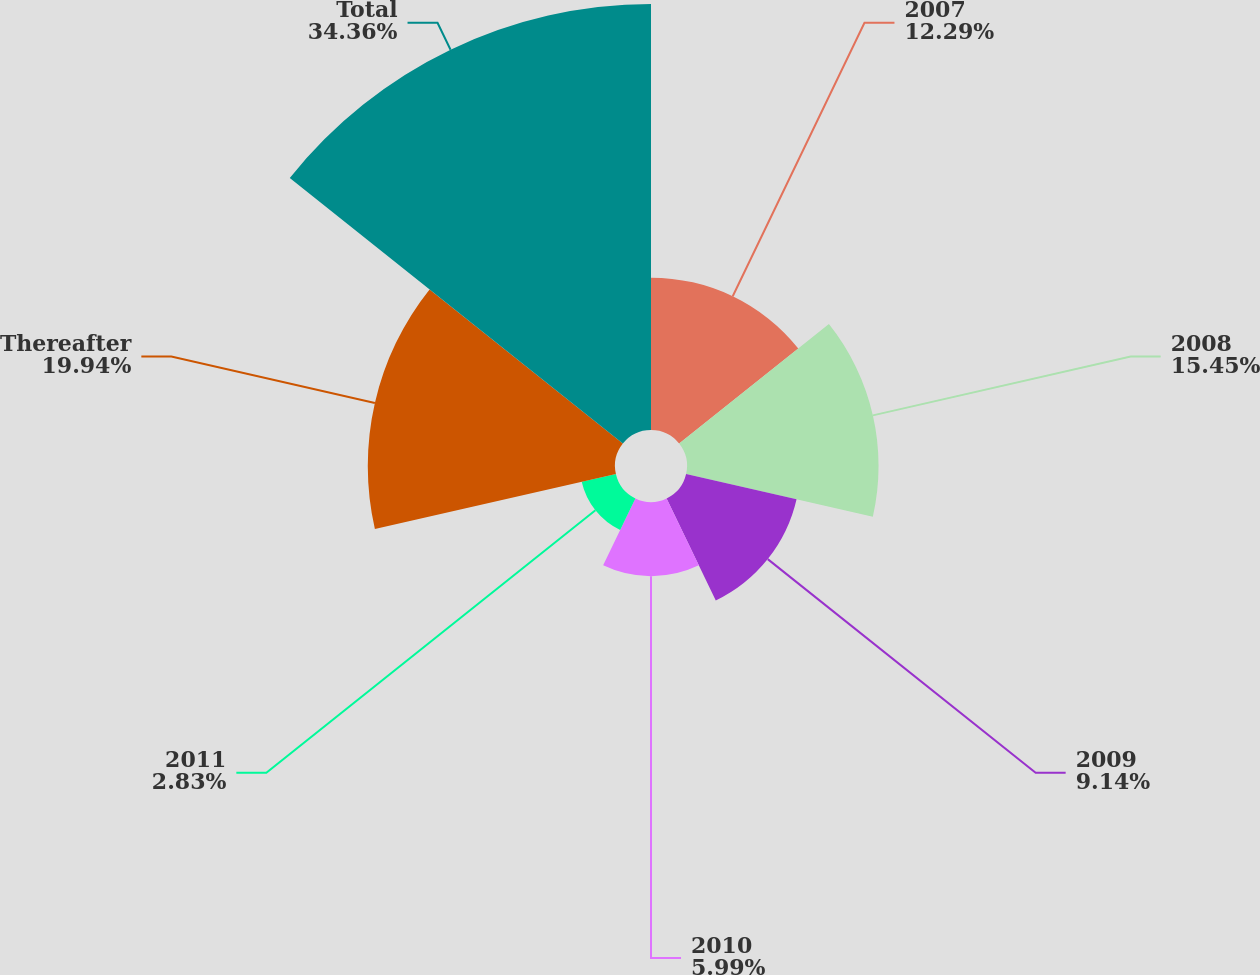Convert chart. <chart><loc_0><loc_0><loc_500><loc_500><pie_chart><fcel>2007<fcel>2008<fcel>2009<fcel>2010<fcel>2011<fcel>Thereafter<fcel>Total<nl><fcel>12.29%<fcel>15.45%<fcel>9.14%<fcel>5.99%<fcel>2.83%<fcel>19.94%<fcel>34.36%<nl></chart> 